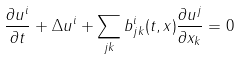<formula> <loc_0><loc_0><loc_500><loc_500>\frac { \partial u ^ { i } } { \partial t } + \Delta u ^ { i } + \sum _ { j k } b ^ { i } _ { j k } ( t , x ) \frac { \partial u ^ { j } } { \partial x _ { k } } = 0</formula> 